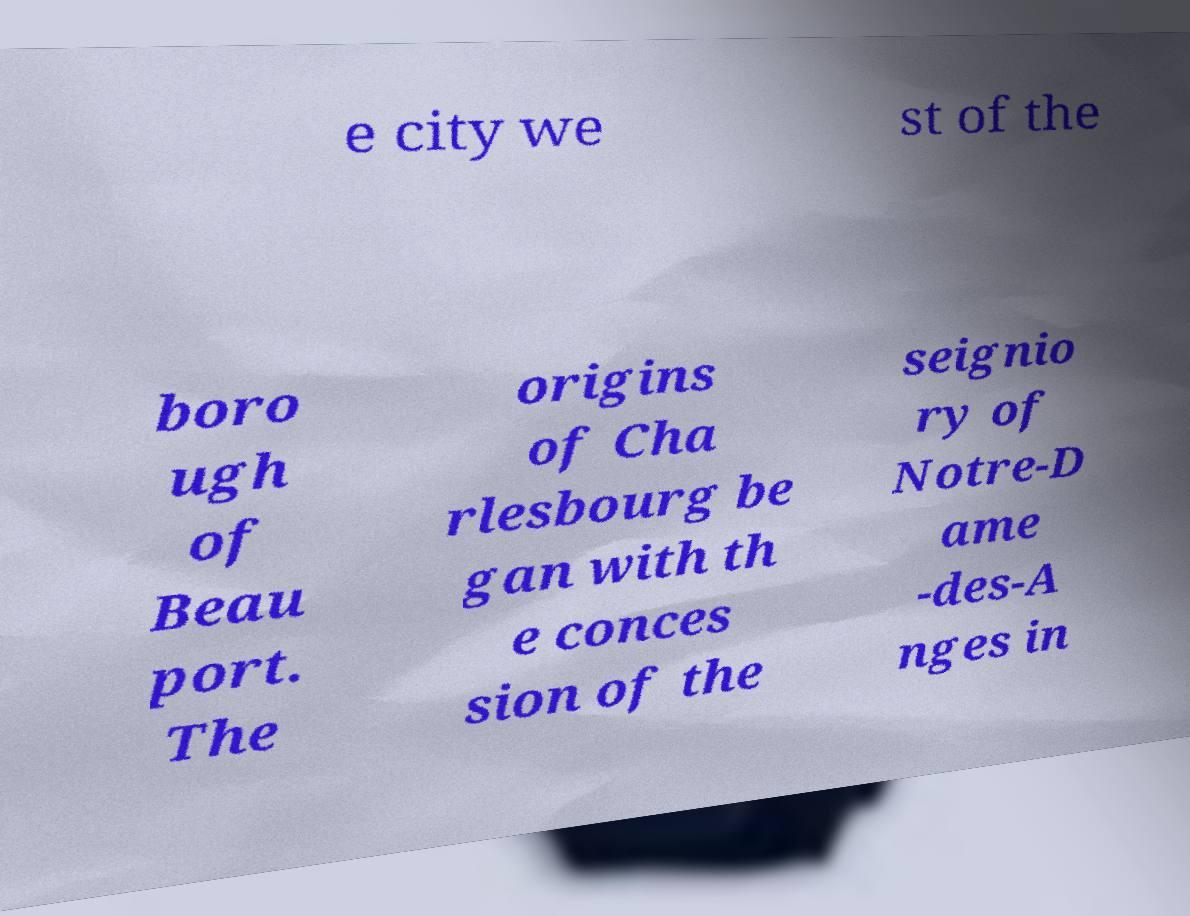Can you accurately transcribe the text from the provided image for me? e city we st of the boro ugh of Beau port. The origins of Cha rlesbourg be gan with th e conces sion of the seignio ry of Notre-D ame -des-A nges in 